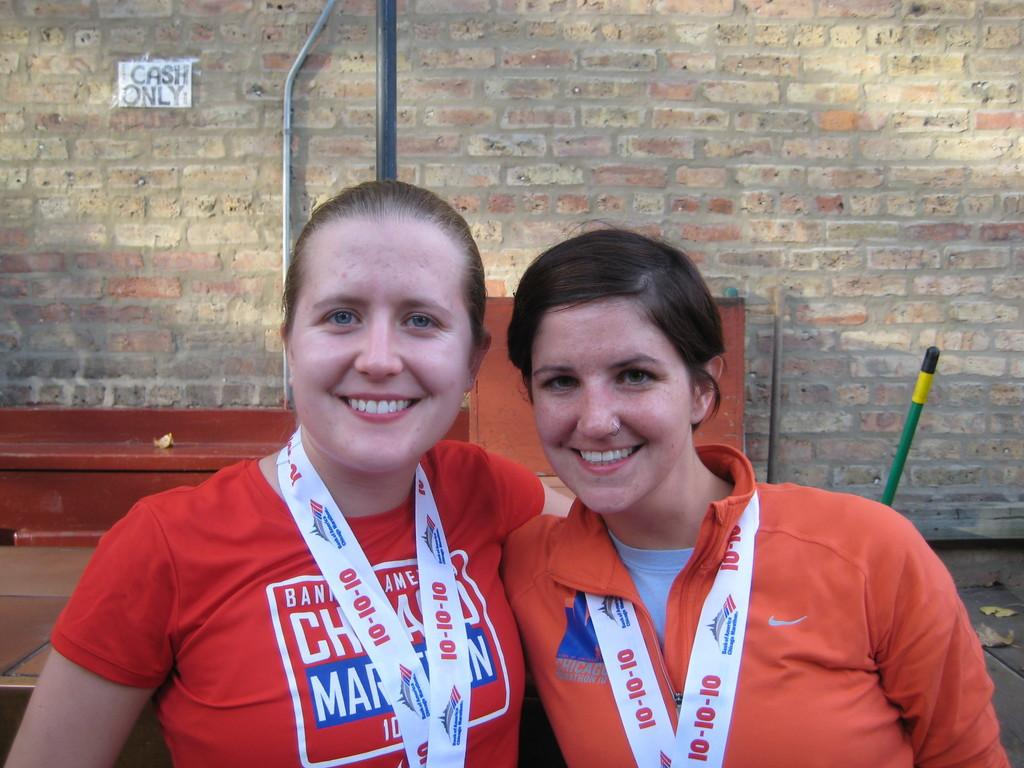<image>
Create a compact narrative representing the image presented. Bank of America sponsored the marathon that the two ladies participated in. 